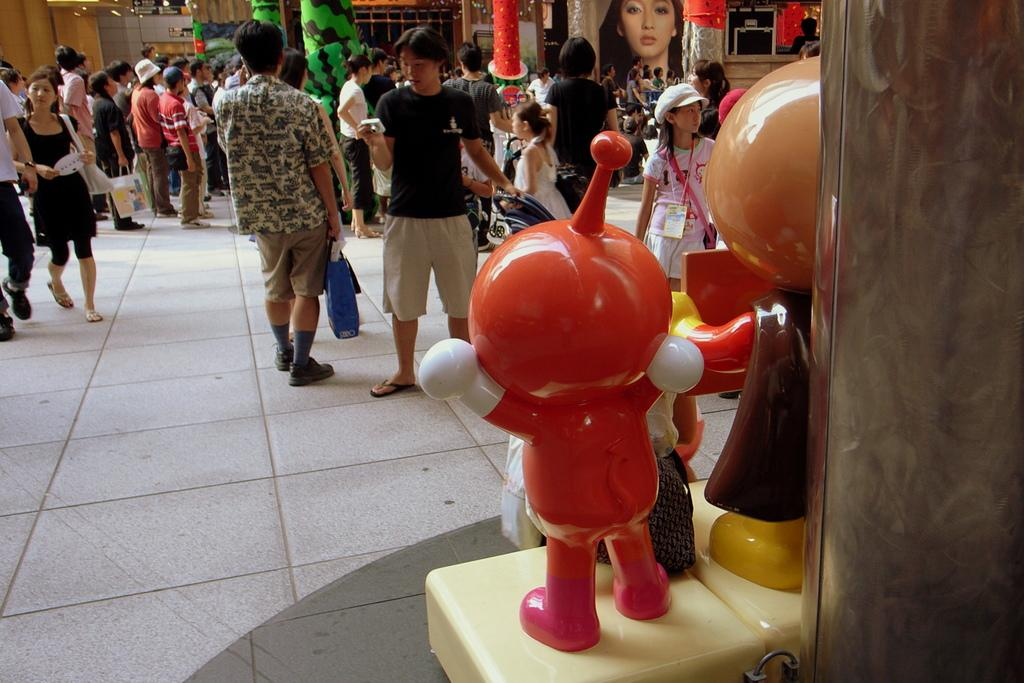What are the people in the image doing? The people in the image are standing on the floor. What can be seen on the right side of the image? There are toys on the right side of the image. What is visible in the background of the image? There is a frame of a woman's face in the background of the image. What language is the iron speaking in the image? There is no iron present in the image, and therefore it cannot be speaking any language. 